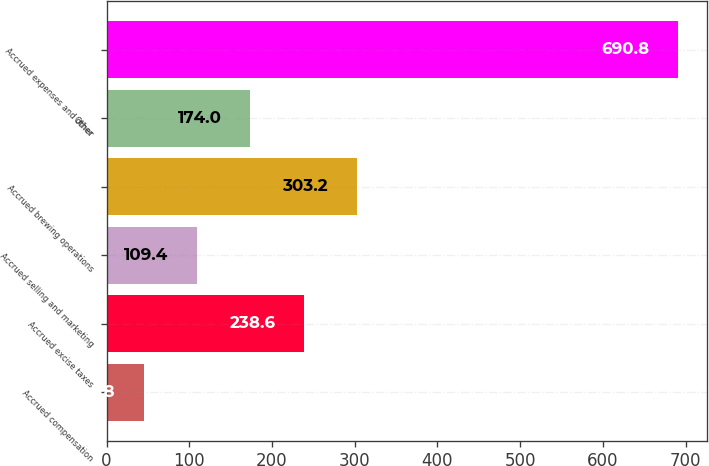<chart> <loc_0><loc_0><loc_500><loc_500><bar_chart><fcel>Accrued compensation<fcel>Accrued excise taxes<fcel>Accrued selling and marketing<fcel>Accrued brewing operations<fcel>Other<fcel>Accrued expenses and other<nl><fcel>44.8<fcel>238.6<fcel>109.4<fcel>303.2<fcel>174<fcel>690.8<nl></chart> 